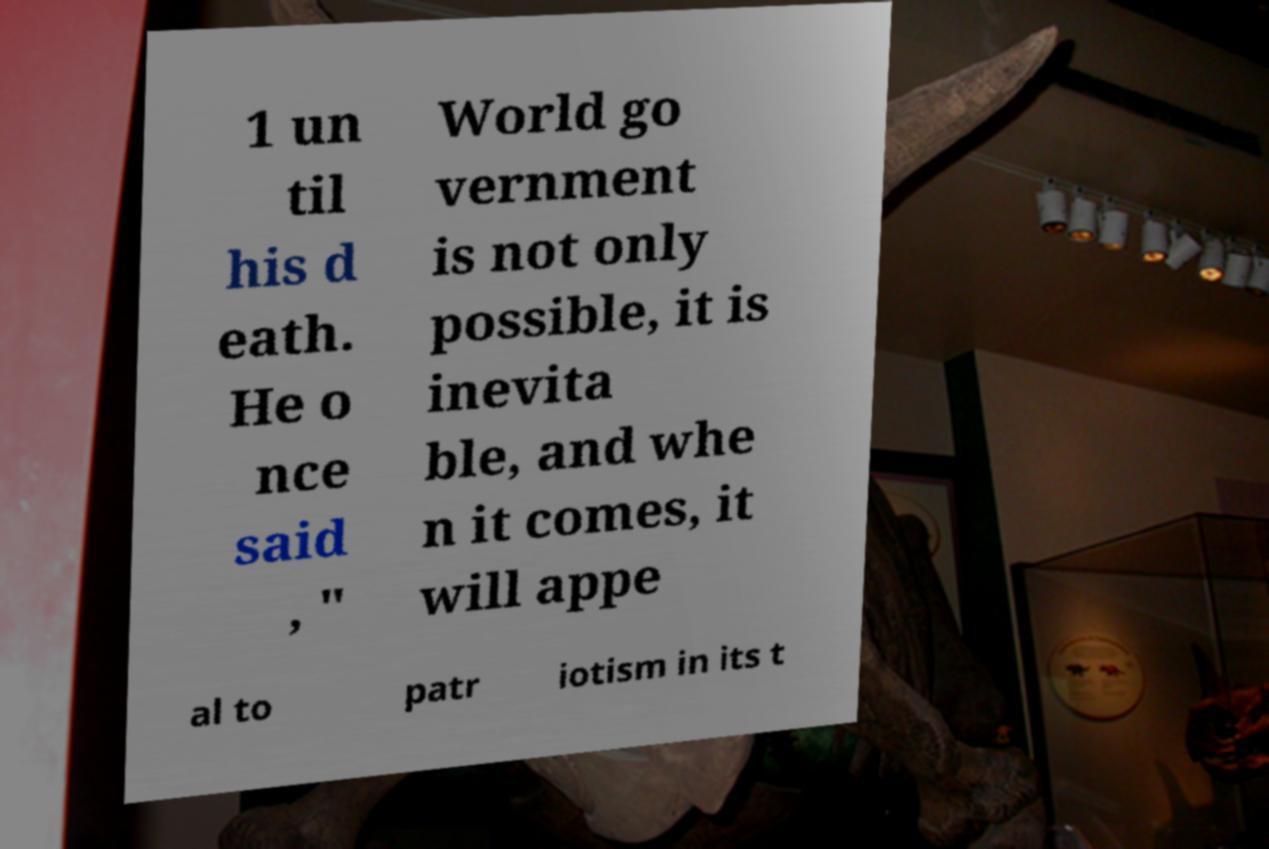Can you read and provide the text displayed in the image?This photo seems to have some interesting text. Can you extract and type it out for me? 1 un til his d eath. He o nce said , " World go vernment is not only possible, it is inevita ble, and whe n it comes, it will appe al to patr iotism in its t 